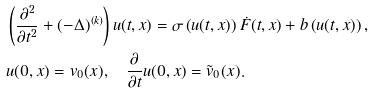Convert formula to latex. <formula><loc_0><loc_0><loc_500><loc_500>& \left ( \frac { \partial ^ { 2 } } { \partial t ^ { 2 } } + ( - \Delta ) ^ { ( k ) } \right ) u ( t , x ) = \sigma \left ( u ( t , x ) \right ) \dot { F } ( t , x ) + b \left ( u ( t , x ) \right ) , \\ & u ( 0 , x ) = v _ { 0 } ( x ) , \quad \frac { \partial } { \partial t } u ( 0 , x ) = \tilde { v } _ { 0 } ( x ) .</formula> 